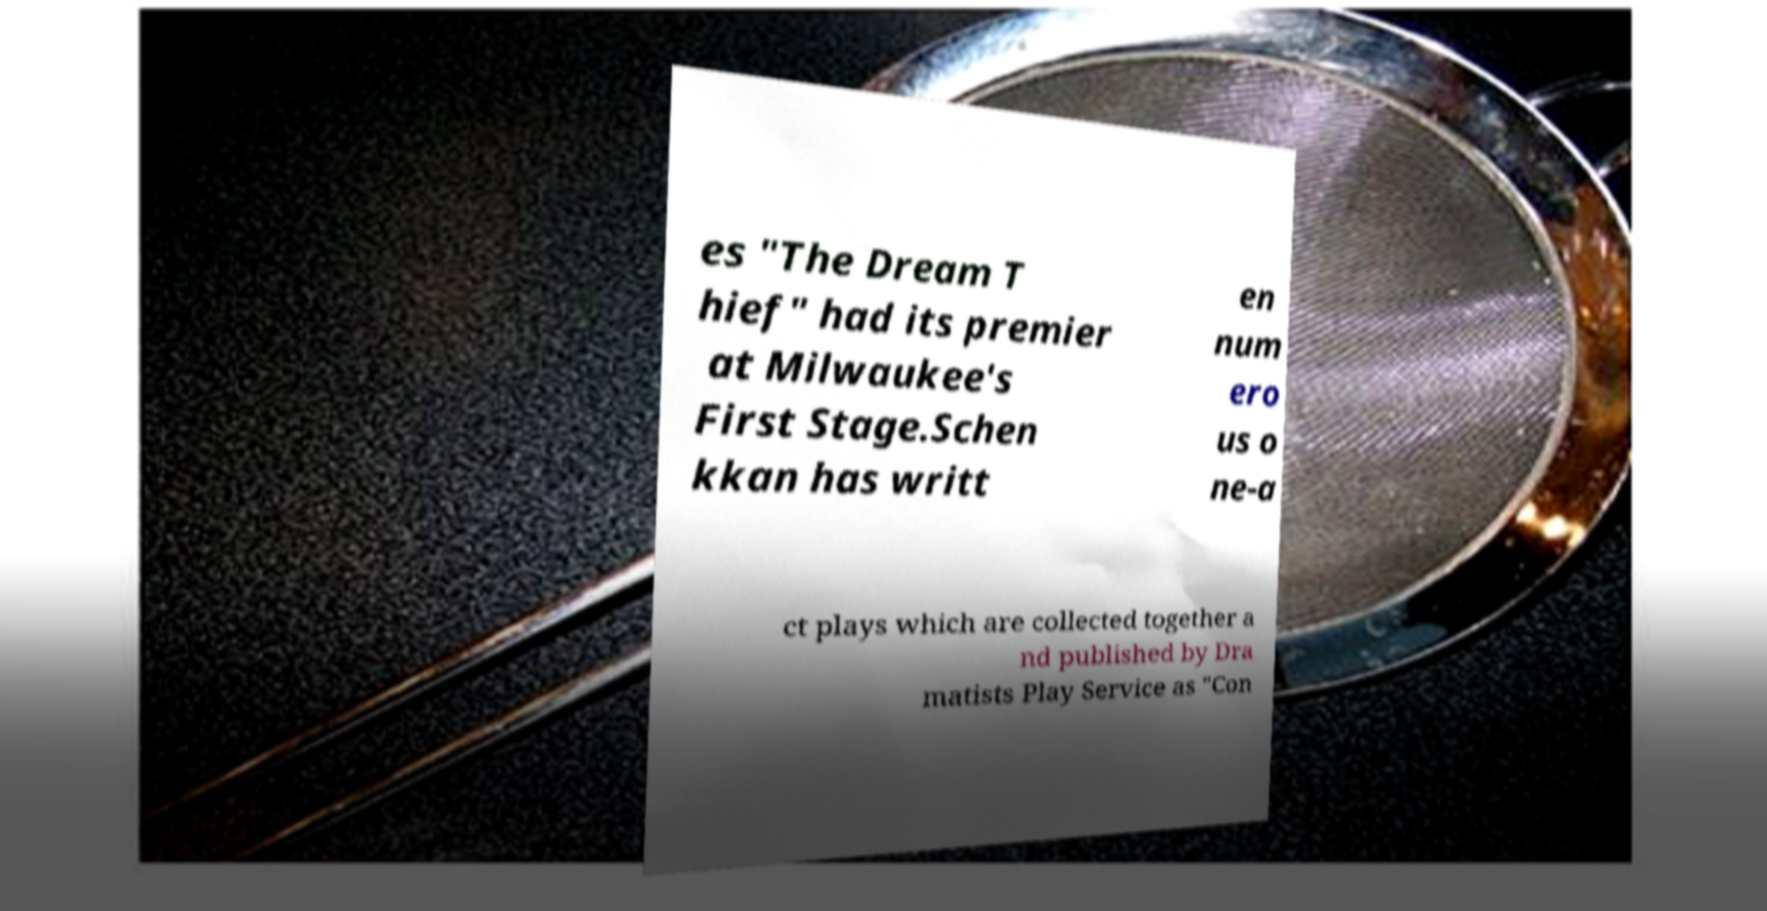What messages or text are displayed in this image? I need them in a readable, typed format. es "The Dream T hief" had its premier at Milwaukee's First Stage.Schen kkan has writt en num ero us o ne-a ct plays which are collected together a nd published by Dra matists Play Service as "Con 